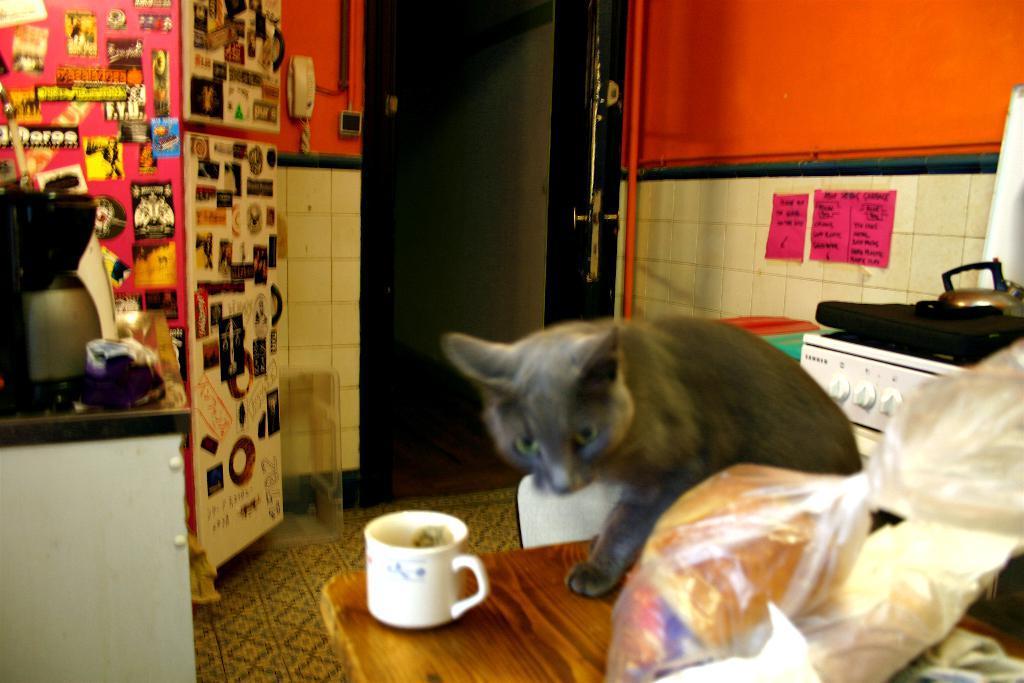How would you summarize this image in a sentence or two? In this image I see a cat which is on the table and I see a cover and a cup on the table too. I see the wallpapers on it and I see a telephone over here and many other equipment over here. 